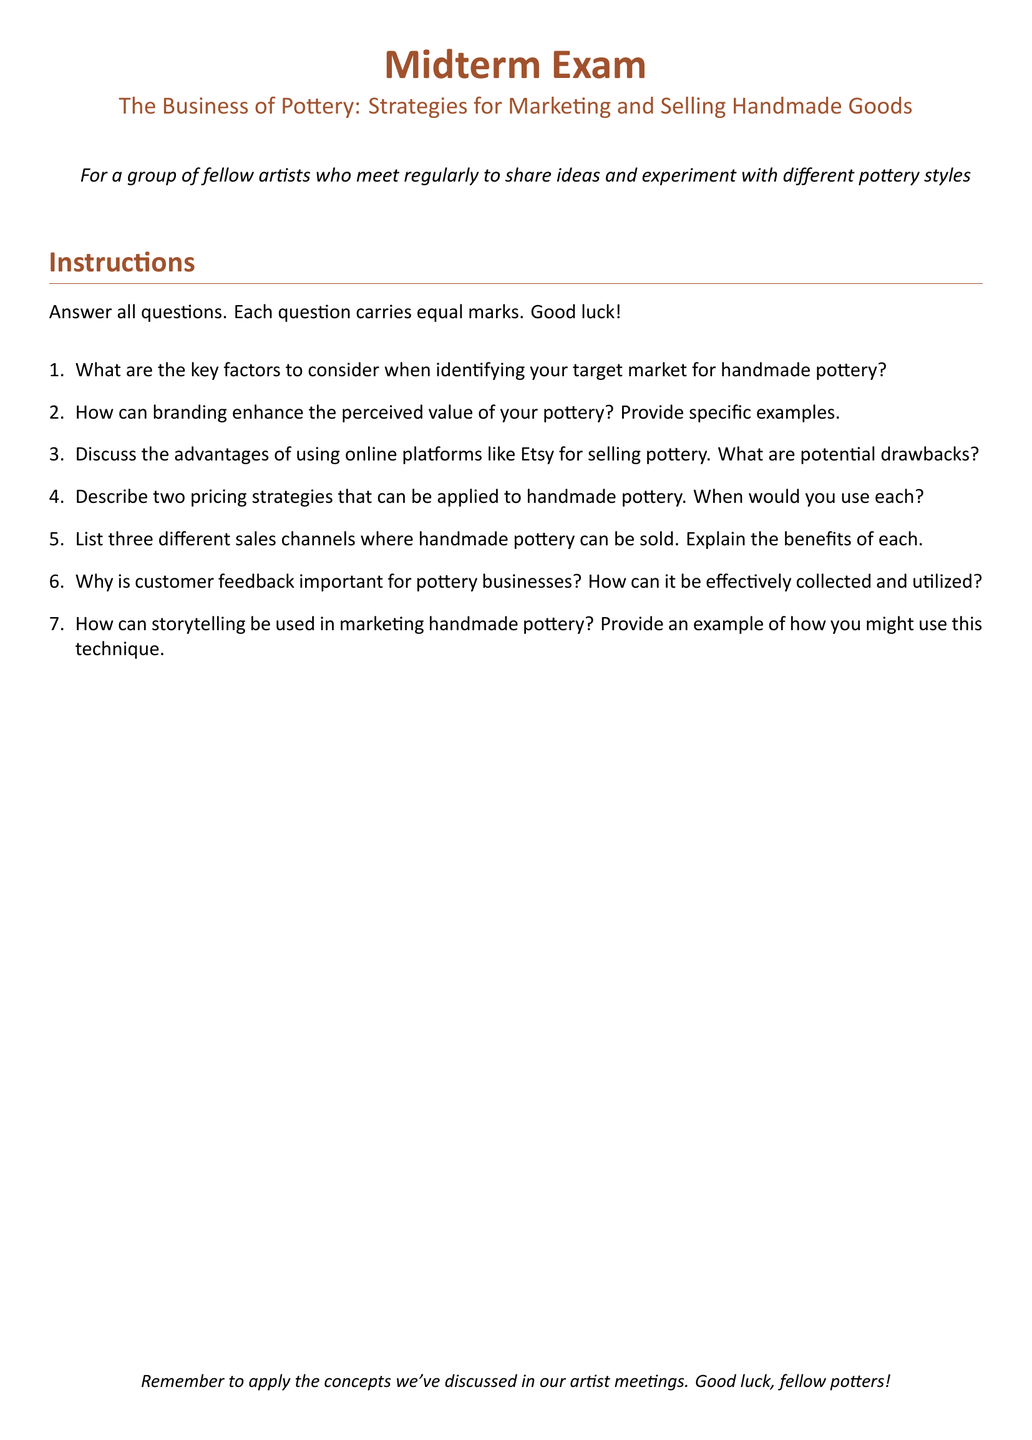What is the title of the midterm exam? The title of the midterm exam is found at the top of the document, stating the topic of discussion.
Answer: The Business of Pottery: Strategies for Marketing and Selling Handmade Goods What is the main instruction for the exam? The main instruction is provided under the "Instructions" section, outlining what the students need to do.
Answer: Answer all questions How many sales channels are listed for selling handmade pottery? The document specifies the number of sales channels in one of the questions, indicating how many channels should be discussed.
Answer: Three What color is used for the main text throughout the document? The color used for the main text is mentioned in the formatting details at the beginning of the document.
Answer: earthbrown What is one potential drawback of using online platforms like Etsy mentioned in the exam? While the specific drawbacks aren't listed in the document, the question prompts consideration of both advantages and disadvantages.
Answer: Potential drawbacks Name one reason why customer feedback is important for pottery businesses. The importance of customer feedback is highlighted in one of the questions asking for its significance.
Answer: Important for improvement What are the two pricing strategies that need to be described in the exam? The specific strategies are not provided in the document but are requested as a requirement for one of the questions.
Answer: Two pricing strategies What is the document type? This refers to the overall classification or purpose of the document, highlighted in its structure.
Answer: Midterm Exam 